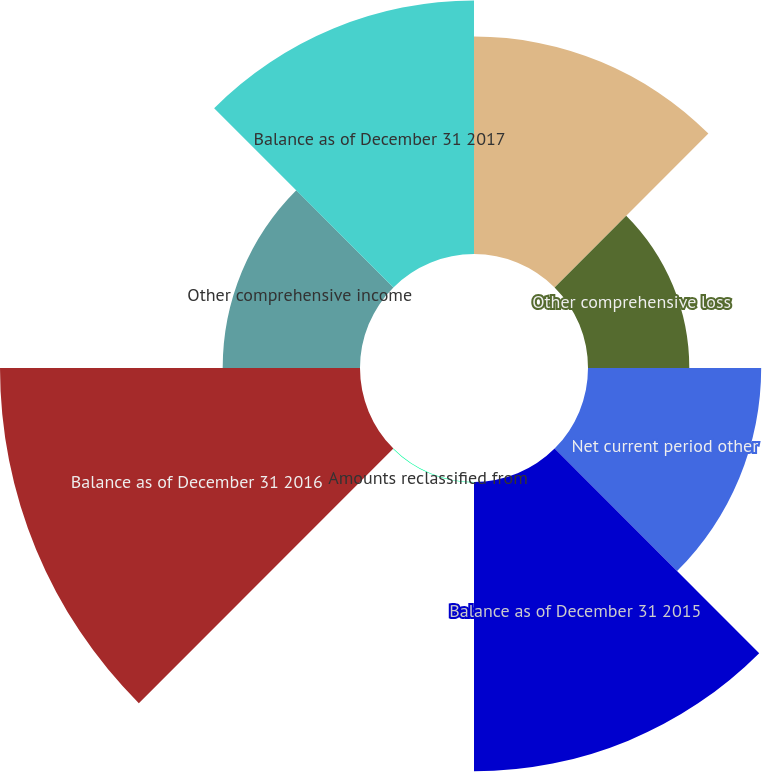<chart> <loc_0><loc_0><loc_500><loc_500><pie_chart><fcel>Balance as of December 31 2014<fcel>Other comprehensive loss<fcel>Net current period other<fcel>Balance as of December 31 2015<fcel>Amounts reclassified from<fcel>Balance as of December 31 2016<fcel>Other comprehensive income<fcel>Balance as of December 31 2017<nl><fcel>14.19%<fcel>6.61%<fcel>11.3%<fcel>18.88%<fcel>0.03%<fcel>23.49%<fcel>8.96%<fcel>16.54%<nl></chart> 